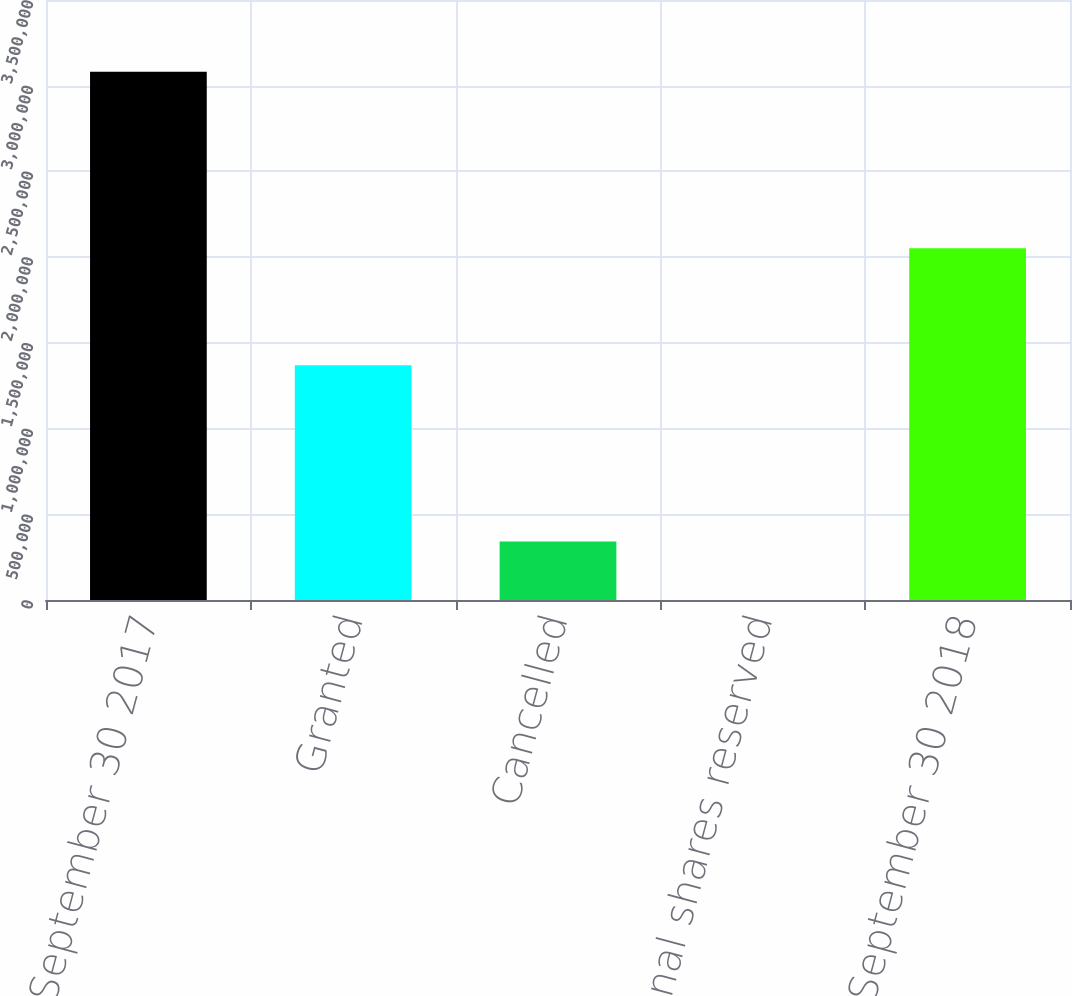<chart> <loc_0><loc_0><loc_500><loc_500><bar_chart><fcel>Balance September 30 2017<fcel>Granted<fcel>Cancelled<fcel>Additional shares reserved<fcel>Balance September 30 2018<nl><fcel>3.08128e+06<fcel>1.36998e+06<fcel>341000<fcel>613<fcel>2.05169e+06<nl></chart> 